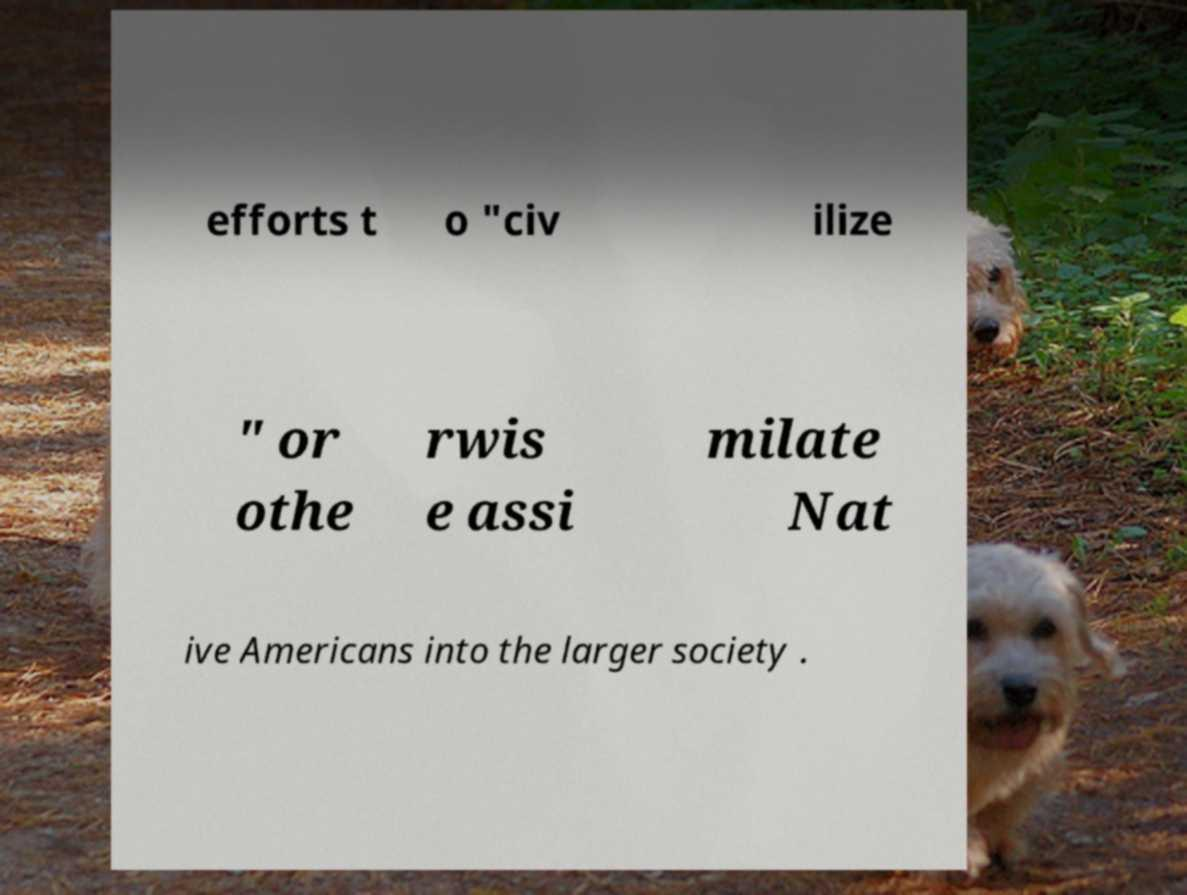Could you extract and type out the text from this image? efforts t o "civ ilize " or othe rwis e assi milate Nat ive Americans into the larger society . 